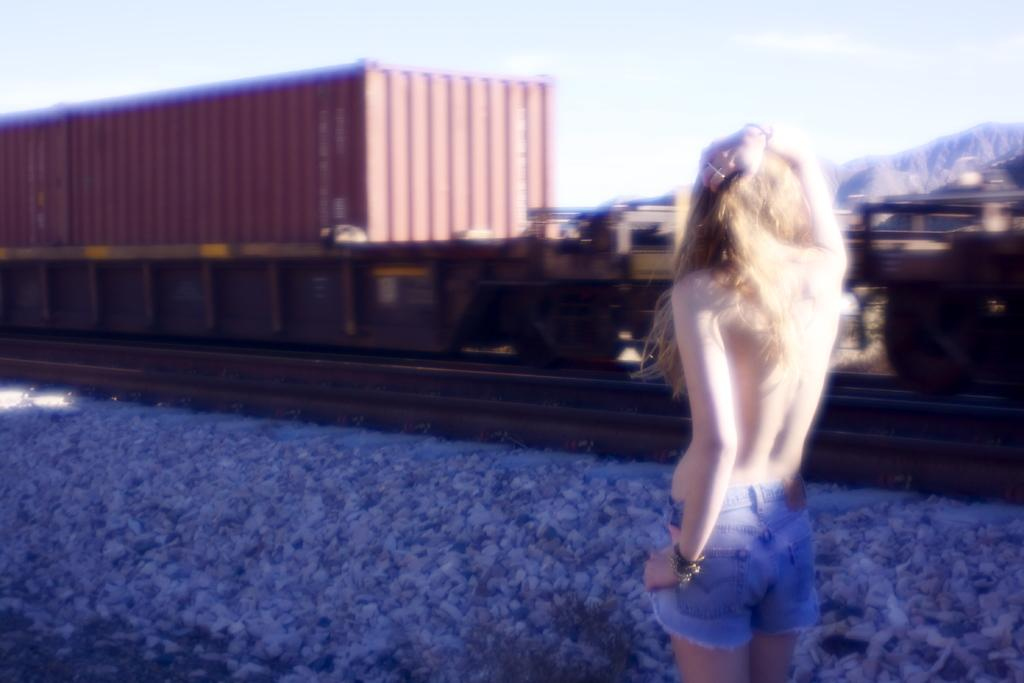Who or what is in the image? There is a person in the image. What is the person standing in front of? The person is standing in front of a train. What is between the person and the train? There are stones between the person and the train. What example of a scale can be seen in the image? There is no scale present in the image. How does the person plan to smash the train in the image? The image does not depict any action or intention to smash the train. 